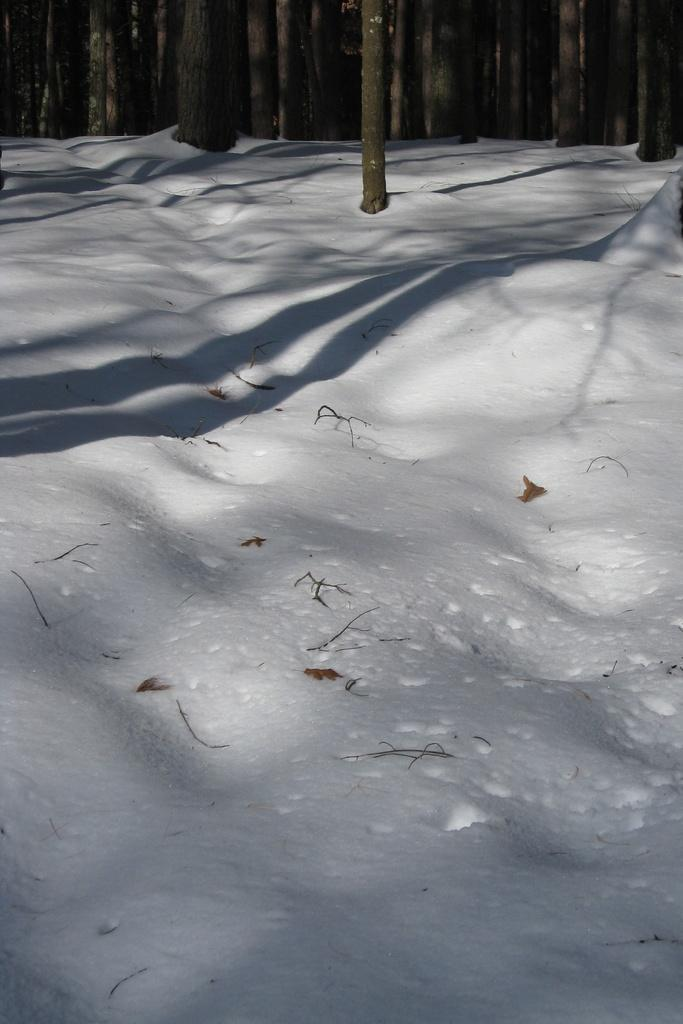What type of vegetation can be seen in the image? There are trees in the image. What is covering the ground in the image? There is snow on the ground in the image. What is the name of the person buried in the cemetery in the image? There is no cemetery present in the image; it features trees and snow-covered ground. 